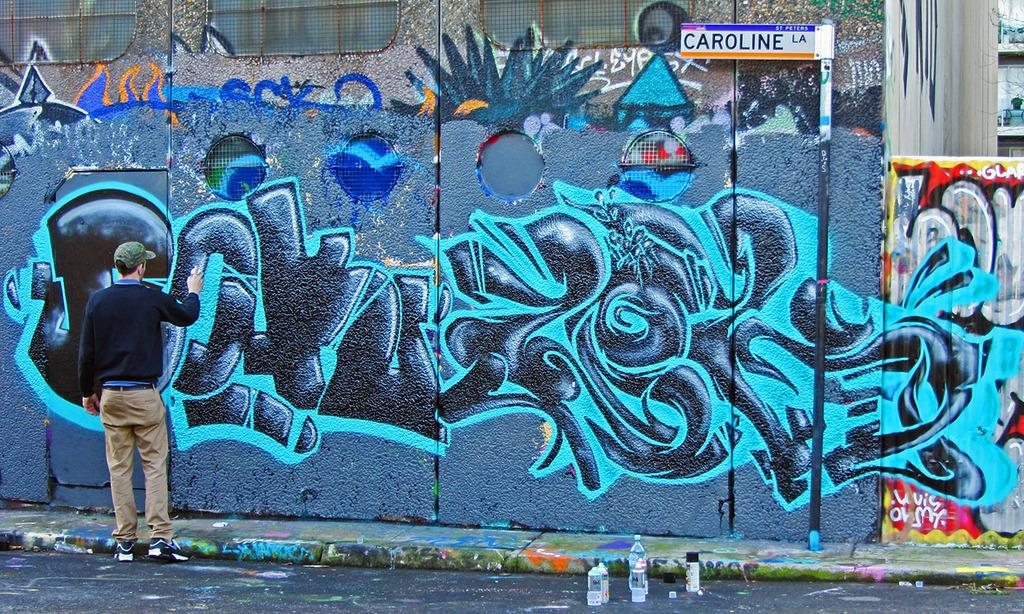What is the person in the image doing? The person is standing in the image. What is the person holding in the image? The person is holding a bottle. What can be seen on the wall in the image? There is graffiti on a wall in the image. What is on the pole in the image? There is a board on a pole in the image. Where are the other bottles located in the image? There are bottles on a surface in the image. What type of shoes is the person wearing in the image? There is no information about the person's shoes in the image, so we cannot determine what type they are wearing. 